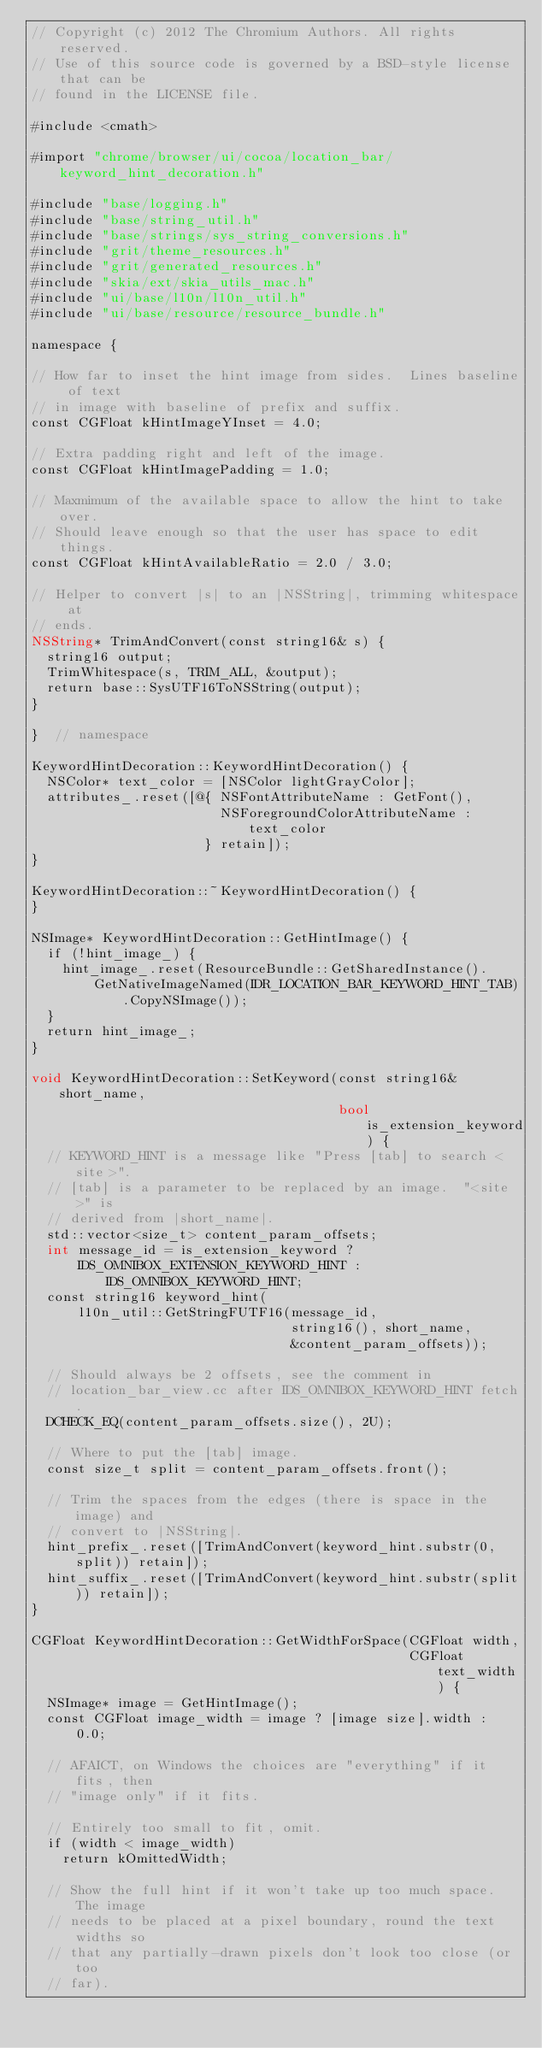<code> <loc_0><loc_0><loc_500><loc_500><_ObjectiveC_>// Copyright (c) 2012 The Chromium Authors. All rights reserved.
// Use of this source code is governed by a BSD-style license that can be
// found in the LICENSE file.

#include <cmath>

#import "chrome/browser/ui/cocoa/location_bar/keyword_hint_decoration.h"

#include "base/logging.h"
#include "base/string_util.h"
#include "base/strings/sys_string_conversions.h"
#include "grit/theme_resources.h"
#include "grit/generated_resources.h"
#include "skia/ext/skia_utils_mac.h"
#include "ui/base/l10n/l10n_util.h"
#include "ui/base/resource/resource_bundle.h"

namespace {

// How far to inset the hint image from sides.  Lines baseline of text
// in image with baseline of prefix and suffix.
const CGFloat kHintImageYInset = 4.0;

// Extra padding right and left of the image.
const CGFloat kHintImagePadding = 1.0;

// Maxmimum of the available space to allow the hint to take over.
// Should leave enough so that the user has space to edit things.
const CGFloat kHintAvailableRatio = 2.0 / 3.0;

// Helper to convert |s| to an |NSString|, trimming whitespace at
// ends.
NSString* TrimAndConvert(const string16& s) {
  string16 output;
  TrimWhitespace(s, TRIM_ALL, &output);
  return base::SysUTF16ToNSString(output);
}

}  // namespace

KeywordHintDecoration::KeywordHintDecoration() {
  NSColor* text_color = [NSColor lightGrayColor];
  attributes_.reset([@{ NSFontAttributeName : GetFont(),
                        NSForegroundColorAttributeName : text_color
                      } retain]);
}

KeywordHintDecoration::~KeywordHintDecoration() {
}

NSImage* KeywordHintDecoration::GetHintImage() {
  if (!hint_image_) {
    hint_image_.reset(ResourceBundle::GetSharedInstance().
        GetNativeImageNamed(IDR_LOCATION_BAR_KEYWORD_HINT_TAB).CopyNSImage());
  }
  return hint_image_;
}

void KeywordHintDecoration::SetKeyword(const string16& short_name,
                                       bool is_extension_keyword) {
  // KEYWORD_HINT is a message like "Press [tab] to search <site>".
  // [tab] is a parameter to be replaced by an image.  "<site>" is
  // derived from |short_name|.
  std::vector<size_t> content_param_offsets;
  int message_id = is_extension_keyword ?
      IDS_OMNIBOX_EXTENSION_KEYWORD_HINT : IDS_OMNIBOX_KEYWORD_HINT;
  const string16 keyword_hint(
      l10n_util::GetStringFUTF16(message_id,
                                 string16(), short_name,
                                 &content_param_offsets));

  // Should always be 2 offsets, see the comment in
  // location_bar_view.cc after IDS_OMNIBOX_KEYWORD_HINT fetch.
  DCHECK_EQ(content_param_offsets.size(), 2U);

  // Where to put the [tab] image.
  const size_t split = content_param_offsets.front();

  // Trim the spaces from the edges (there is space in the image) and
  // convert to |NSString|.
  hint_prefix_.reset([TrimAndConvert(keyword_hint.substr(0, split)) retain]);
  hint_suffix_.reset([TrimAndConvert(keyword_hint.substr(split)) retain]);
}

CGFloat KeywordHintDecoration::GetWidthForSpace(CGFloat width,
                                                CGFloat text_width) {
  NSImage* image = GetHintImage();
  const CGFloat image_width = image ? [image size].width : 0.0;

  // AFAICT, on Windows the choices are "everything" if it fits, then
  // "image only" if it fits.

  // Entirely too small to fit, omit.
  if (width < image_width)
    return kOmittedWidth;

  // Show the full hint if it won't take up too much space.  The image
  // needs to be placed at a pixel boundary, round the text widths so
  // that any partially-drawn pixels don't look too close (or too
  // far).</code> 